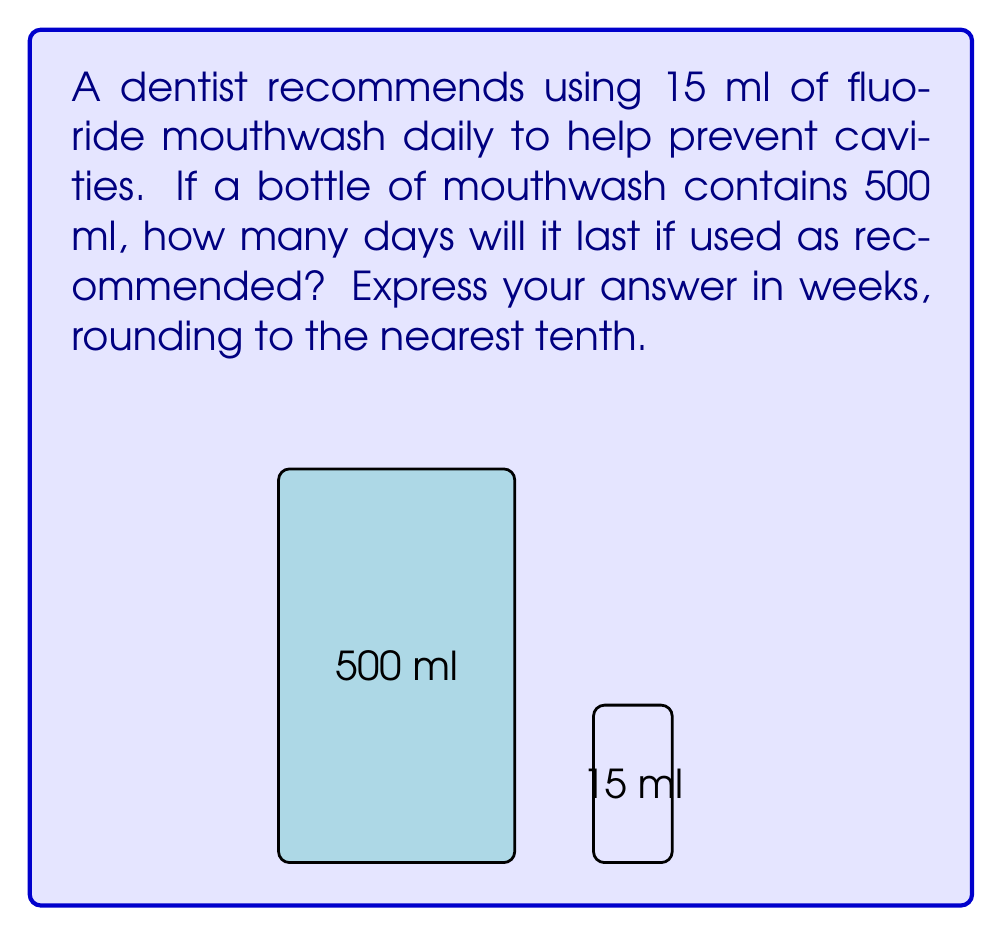Can you answer this question? Let's approach this step-by-step:

1) First, we need to calculate how many days the 500 ml bottle will last:

   $\text{Number of days} = \frac{\text{Total volume}}{\text{Daily usage}}$
   
   $\text{Number of days} = \frac{500 \text{ ml}}{15 \text{ ml/day}} = 33.33 \text{ days}$

2) Now, we need to convert days to weeks:

   $\text{Number of weeks} = \frac{\text{Number of days}}{7 \text{ days/week}}$
   
   $\text{Number of weeks} = \frac{33.33}{7} = 4.76 \text{ weeks}$

3) Rounding to the nearest tenth:

   $4.76 \text{ weeks} \approx 4.8 \text{ weeks}$

This result shows that consistent daily use of fluoride mouthwash, which the person might have neglected in their youth, can be maintained for nearly 5 weeks with a single 500 ml bottle.
Answer: 4.8 weeks 